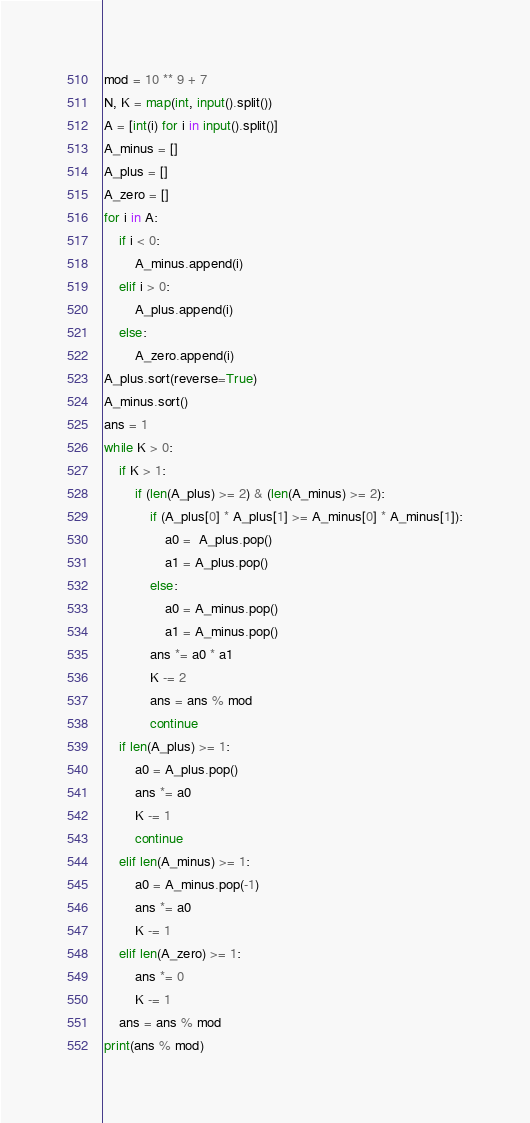<code> <loc_0><loc_0><loc_500><loc_500><_Python_>mod = 10 ** 9 + 7
N, K = map(int, input().split())
A = [int(i) for i in input().split()]
A_minus = []
A_plus = []
A_zero = []
for i in A:
    if i < 0:
        A_minus.append(i)
    elif i > 0:
        A_plus.append(i)
    else:
        A_zero.append(i)
A_plus.sort(reverse=True)
A_minus.sort()
ans = 1
while K > 0:
    if K > 1:
        if (len(A_plus) >= 2) & (len(A_minus) >= 2):
            if (A_plus[0] * A_plus[1] >= A_minus[0] * A_minus[1]):
                a0 =  A_plus.pop()
                a1 = A_plus.pop()
            else:
                a0 = A_minus.pop()
                a1 = A_minus.pop()
            ans *= a0 * a1
            K -= 2
            ans = ans % mod
            continue
    if len(A_plus) >= 1:
        a0 = A_plus.pop()
        ans *= a0
        K -= 1
        continue
    elif len(A_minus) >= 1:
        a0 = A_minus.pop(-1)
        ans *= a0
        K -= 1
    elif len(A_zero) >= 1:
        ans *= 0
        K -= 1
    ans = ans % mod
print(ans % mod)</code> 